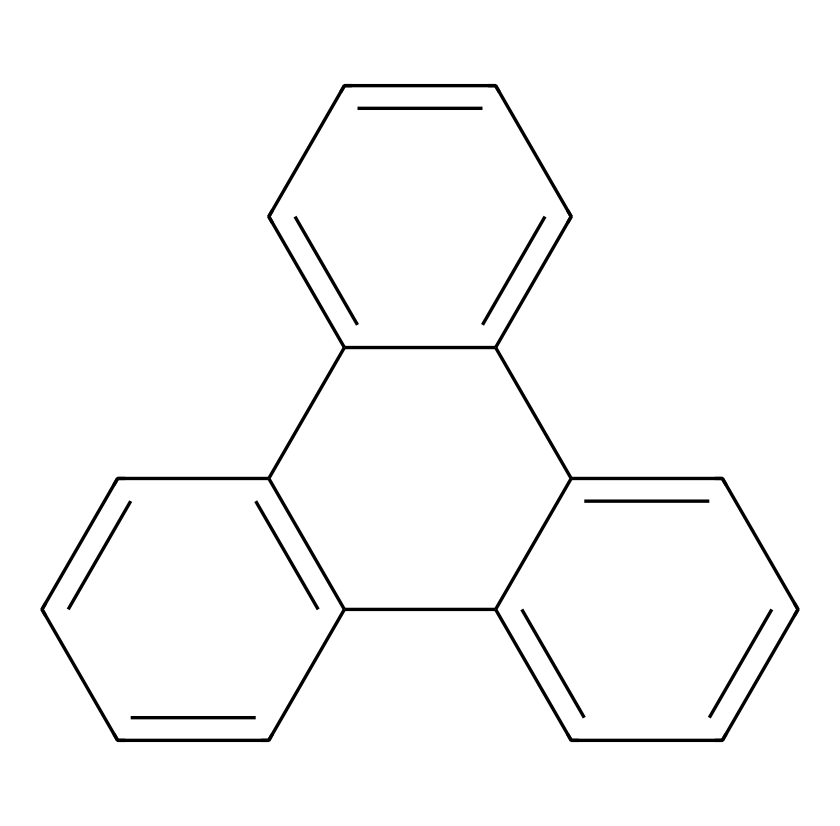What is the total number of carbon atoms in the chemical structure? By examining the provided SMILES representation, we count each carbon atom symbol 'C'. There are a total of 16 carbon atoms in the structure.
Answer: 16 How many aromatic rings are present in the structure? The structure contains multiple connected aromatic rings. By analyzing the continuous cycles of carbon atoms in conjugation, we identify 4 distinct aromatic rings.
Answer: 4 What is the degree of unsaturation in this compound? The degree of unsaturation can be calculated using the formula (2C + 2 + N - H - X)/2. In this case, there are 16 carbons and no other elements affecting the count significantly, leading to a degree of unsaturation of 8.
Answer: 8 What type of quantum dot does this structure represent? This chemical structure represents graphene quantum dots, known for their unique electronic properties and potential applications in photonics and optoelectronics.
Answer: graphene quantum dots What type of bonding is predominant in this chemical? The predominant bonding in this chemical is covalent bonding, as inferred from the presence of many carbon atoms forming stable bonds with other carbons.
Answer: covalent How does the structure promote quantum confinement effects? The specific arrangement and size at the nanoscale of the carbon atoms in the quantum dot lead to quantum confinement, which alters the electronic properties, allowing for distinct optical behaviors.
Answer: quantum confinement What property of this quantum dot affects its color in visual applications? The size of the graphene quantum dot affects its bandgap, which directly influences the color emitted due to quantum confinement effects.
Answer: bandgap 